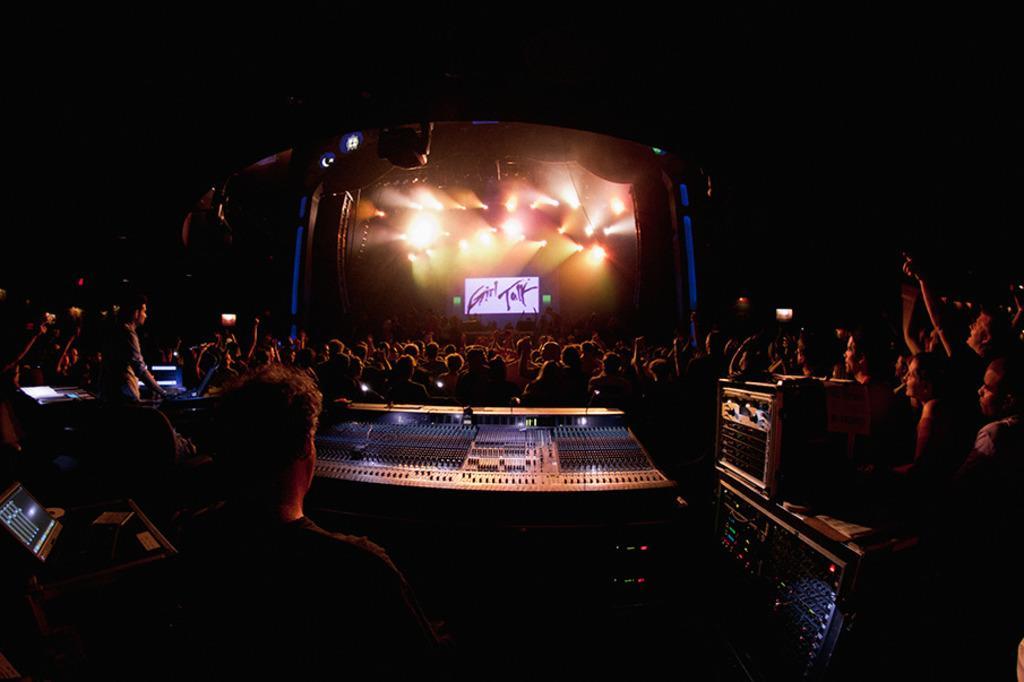How would you summarize this image in a sentence or two? In this image we can see DJ equipment, laptop, group of people, roof, lights, screen, and other objects. There is a dark background. 